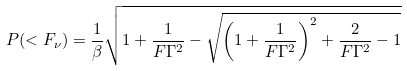<formula> <loc_0><loc_0><loc_500><loc_500>P ( < F _ { \nu } ) = \frac { 1 } { \beta } \sqrt { 1 + \frac { 1 } { F \Gamma ^ { 2 } } - \sqrt { \left ( 1 + \frac { 1 } { F \Gamma ^ { 2 } } \right ) ^ { 2 } + \frac { 2 } { F \Gamma ^ { 2 } } - 1 } }</formula> 